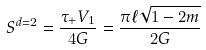Convert formula to latex. <formula><loc_0><loc_0><loc_500><loc_500>S ^ { d = 2 } = \frac { \tau _ { + } V _ { 1 } } { 4 G } = \frac { \pi \ell \sqrt { 1 - 2 m } } { 2 G }</formula> 